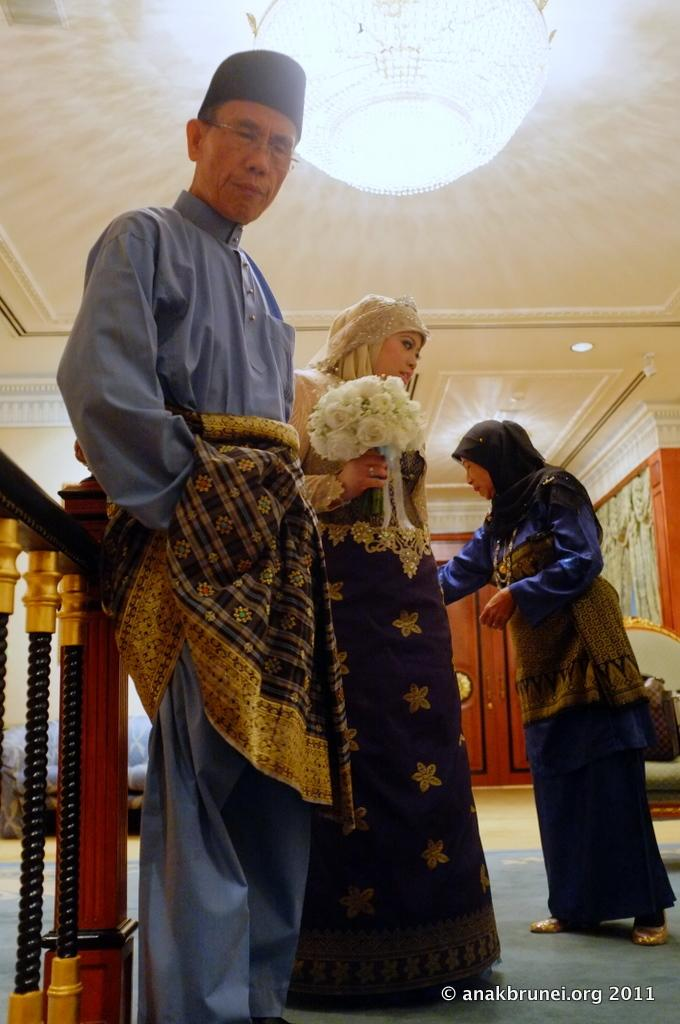How many people are in the image? There are three people in the image. Where are the people located in the image? The people are on the floor. What can be seen in the background of the image? There is a wall, a roof, lights, and some objects in the background of the image. Is there any text visible in the image? Yes, there is some text visible in the bottom right corner of the image. Can you see a window in the image? There is no window visible in the image. Is there a coach present in the image? There is no coach present in the image. 